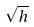<formula> <loc_0><loc_0><loc_500><loc_500>\sqrt { h }</formula> 